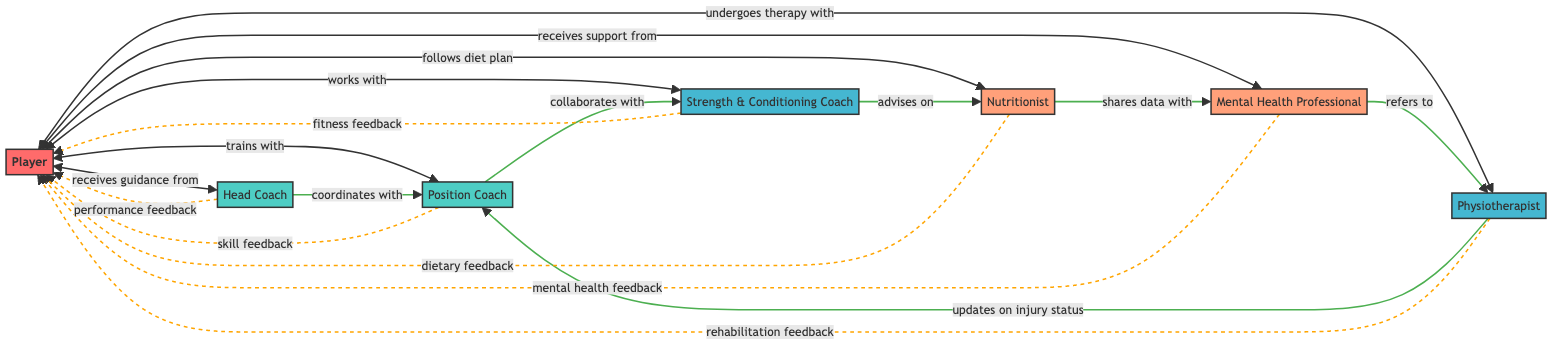What is the total number of nodes in the diagram? The diagram lists several entities involved in player development: Player, Head Coach, Position Coach, Strength & Conditioning Coach, Nutritionist, Mental Health Professional, and Physiotherapist. There are a total of 7 nodes.
Answer: 7 Which node does the Player receive guidance from? Looking at the edges connected to the Player, it's clear that the Player receives guidance from the Head Coach.
Answer: Head Coach What type of relationship exists between the Position Coach and the Strength & Conditioning Coach? The diagram indicates a 'collaborates with' relationship between the Position Coach and the Strength & Conditioning Coach, connecting the two nodes with the respective label.
Answer: collaborates with How many feedback loops are there in total? The feedback loops listed show various types of feedback directed towards the Player from different professionals. There are 6 distinct feedback loops indicated in the diagram.
Answer: 6 From the Strength & Conditioning Coach, what type of feedback does the Player receive? The diagram specifies that the feedback from the Strength & Conditioning Coach directed to the Player is labeled as 'fitness feedback', which suggests a focus on the Player's physical condition.
Answer: fitness feedback Who collaborates with the Position Coach? The diagram shows that the Position Coach collaborates with the Strength & Conditioning Coach, meaning these two coaches work together within the Player's development network.
Answer: Strength & Conditioning Coach Which professional shares data with the Mental Health Professional? According to the diagram, the Nutritionist shares data with the Mental Health Professional, indicating some level of integration between dietary considerations and mental health support.
Answer: Nutritionist Which role mainly oversees strategy? In the context of player development and the diagram, it is the Head Coach who is designated as overseeing strategy, connecting to multiple nodes that indicate this role.
Answer: Head Coach What type of feedback does the Nutritionist provide to the Player? The diagram clearly states that the Nutritionist provides 'dietary feedback' to the Player, showing a direct interaction focused on nutrition and diet.
Answer: dietary feedback 